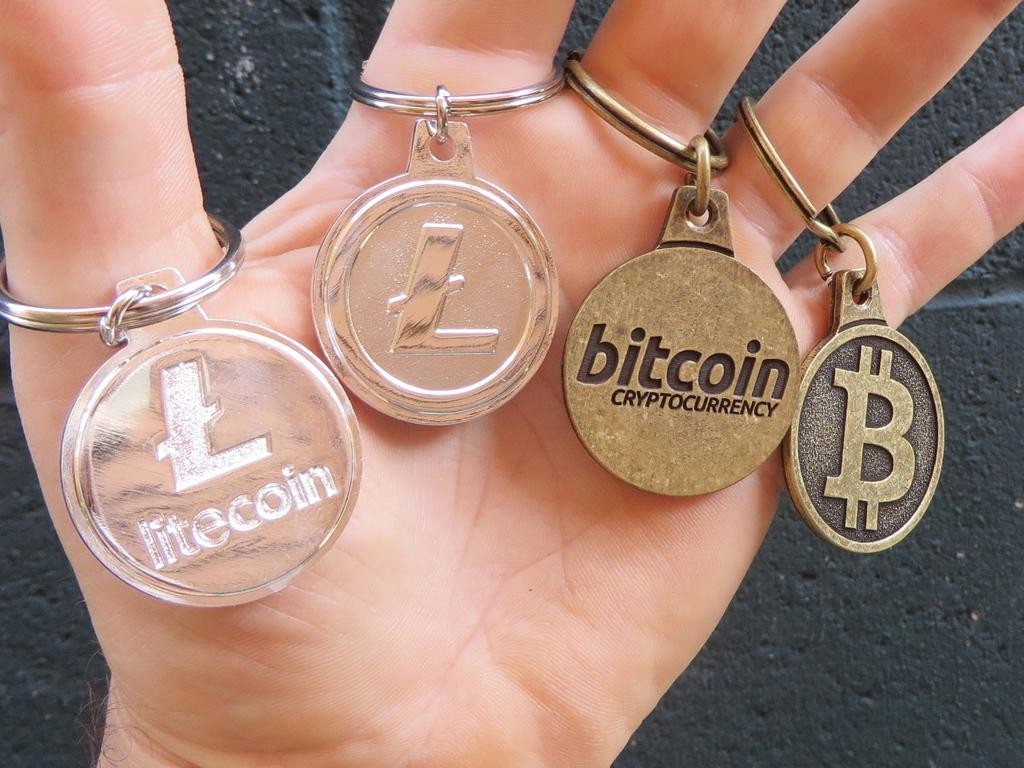<image>
Summarize the visual content of the image. A person holds several keychains, including one that says litecoin. 